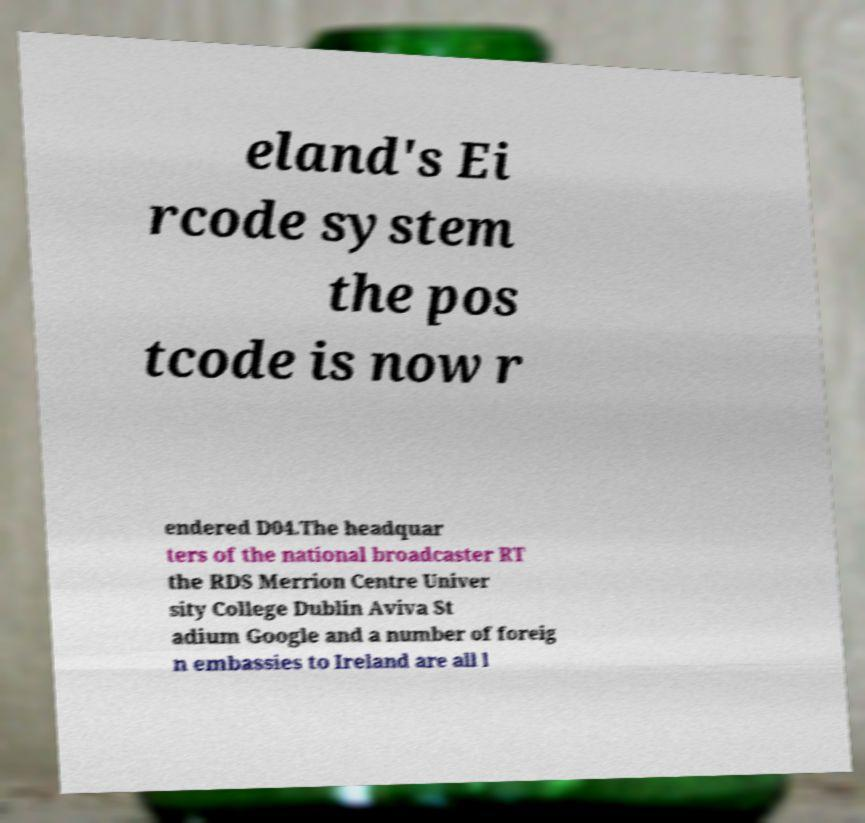I need the written content from this picture converted into text. Can you do that? eland's Ei rcode system the pos tcode is now r endered D04.The headquar ters of the national broadcaster RT the RDS Merrion Centre Univer sity College Dublin Aviva St adium Google and a number of foreig n embassies to Ireland are all l 